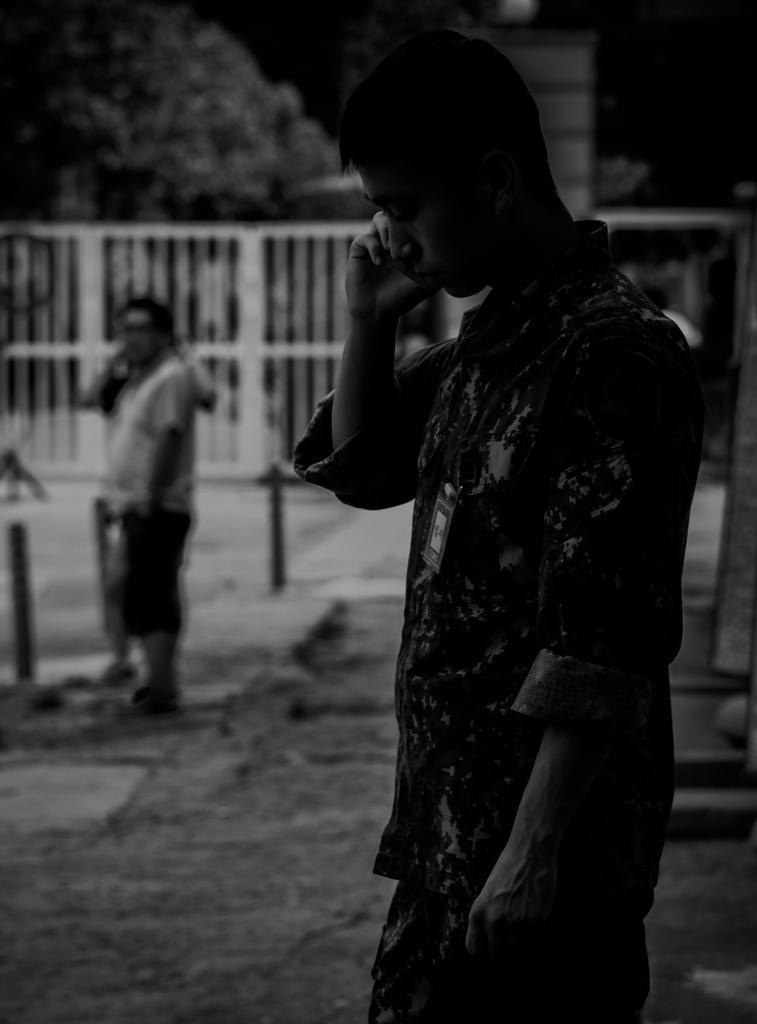Could you give a brief overview of what you see in this image? In this image we can see a man standing. In the background we can see the person standing on the path. We can also see the fence, pillar and also the trees and it is a black and white image. 